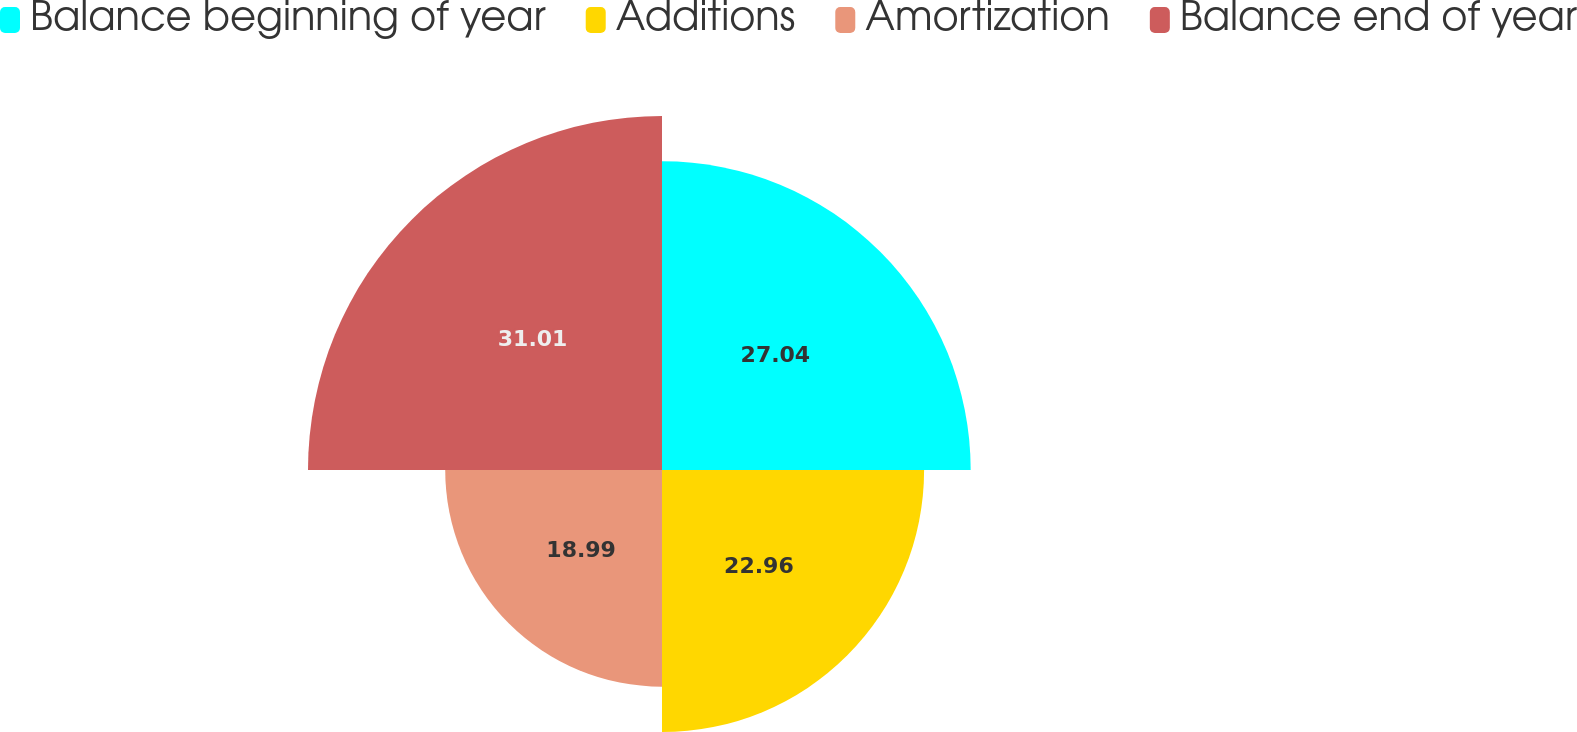Convert chart to OTSL. <chart><loc_0><loc_0><loc_500><loc_500><pie_chart><fcel>Balance beginning of year<fcel>Additions<fcel>Amortization<fcel>Balance end of year<nl><fcel>27.04%<fcel>22.96%<fcel>18.99%<fcel>31.01%<nl></chart> 